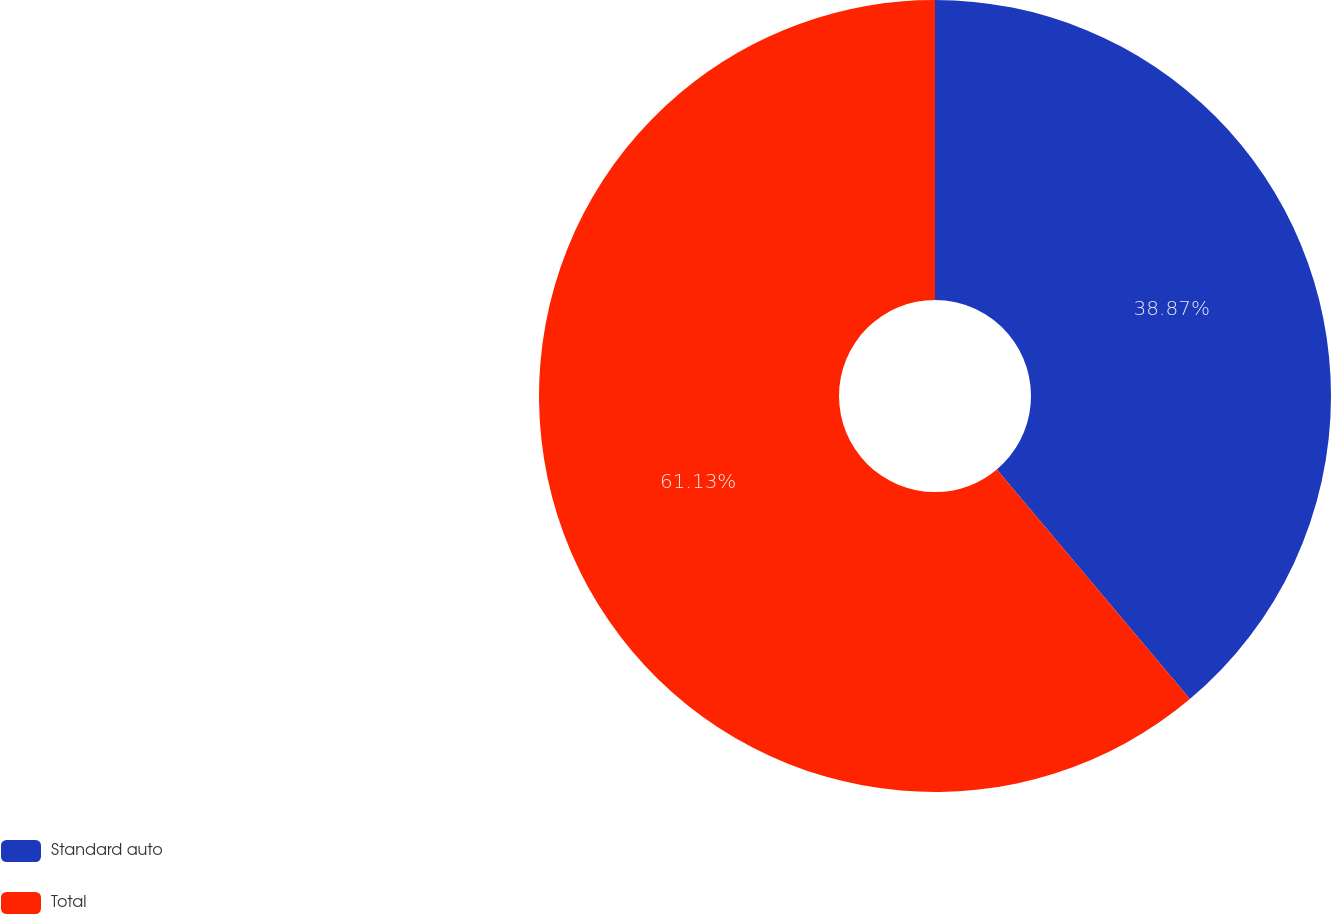Convert chart to OTSL. <chart><loc_0><loc_0><loc_500><loc_500><pie_chart><fcel>Standard auto<fcel>Total<nl><fcel>38.87%<fcel>61.13%<nl></chart> 